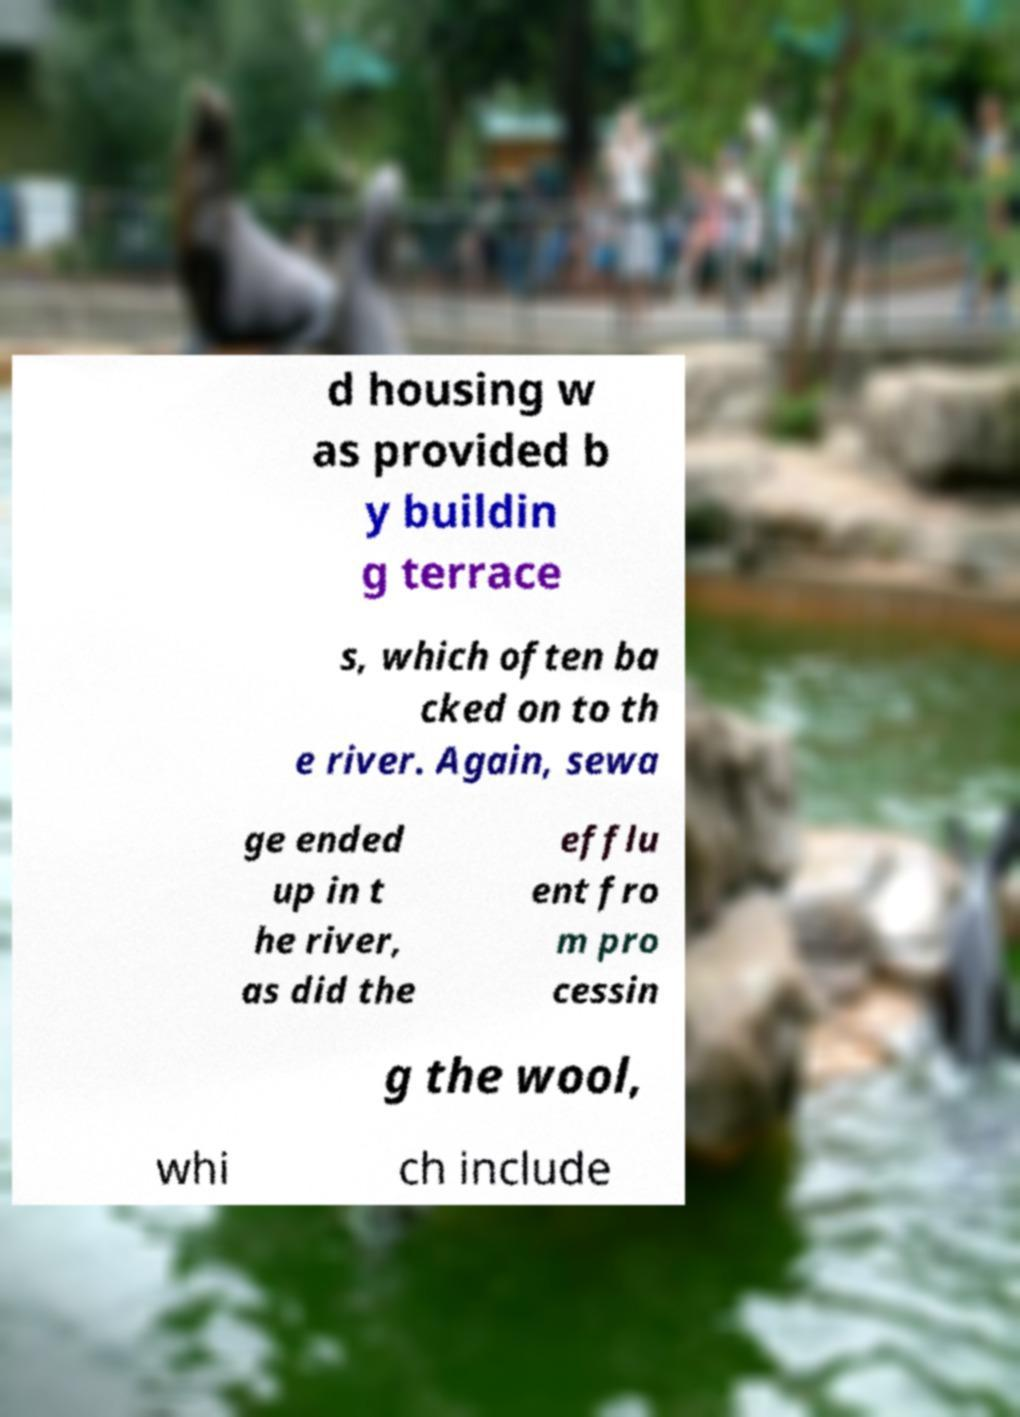What messages or text are displayed in this image? I need them in a readable, typed format. d housing w as provided b y buildin g terrace s, which often ba cked on to th e river. Again, sewa ge ended up in t he river, as did the efflu ent fro m pro cessin g the wool, whi ch include 